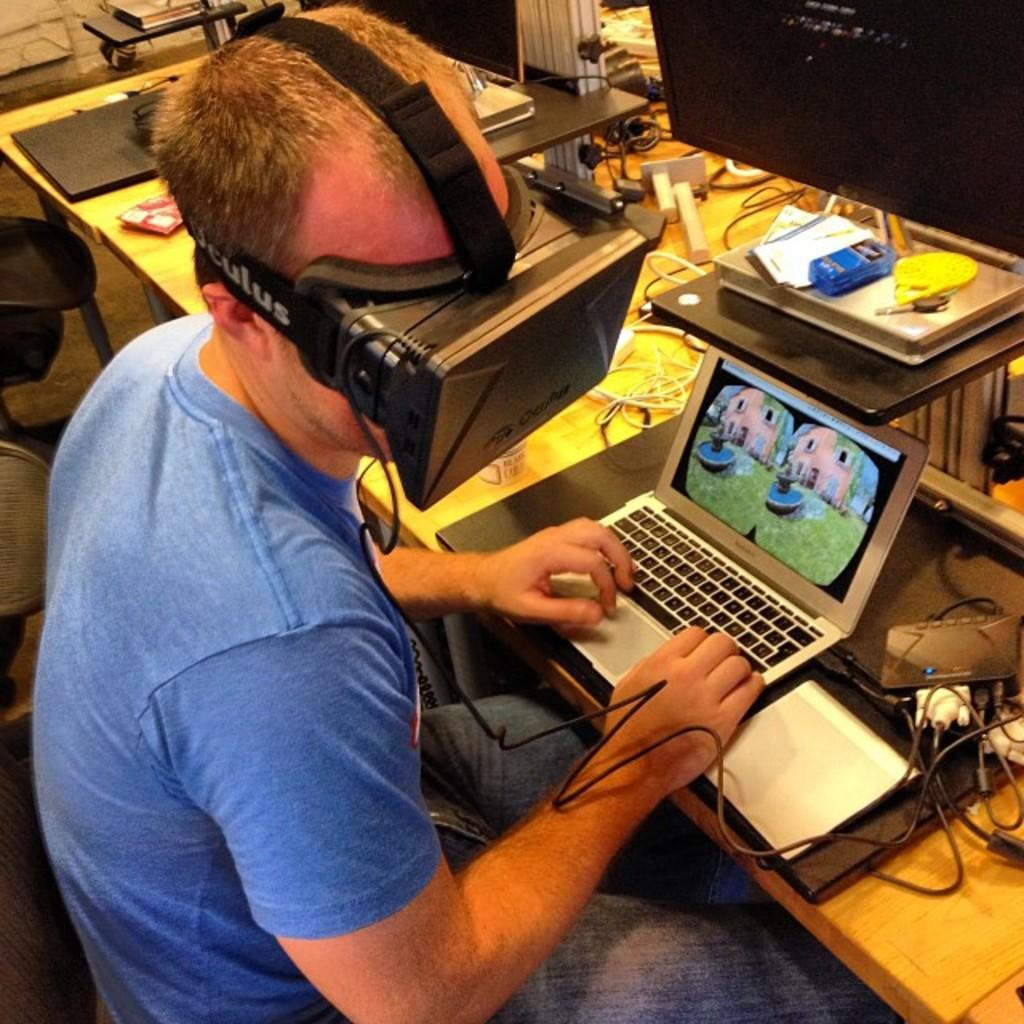Provide a one-sentence caption for the provided image. Man on laptop wearing an Oculus virtual reality veiwer. 